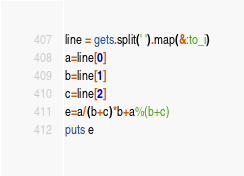<code> <loc_0><loc_0><loc_500><loc_500><_Ruby_>line = gets.split(' ').map(&:to_i)
a=line[0]
b=line[1]
c=line[2]
e=a/(b+c)*b+a%(b+c)
puts e</code> 